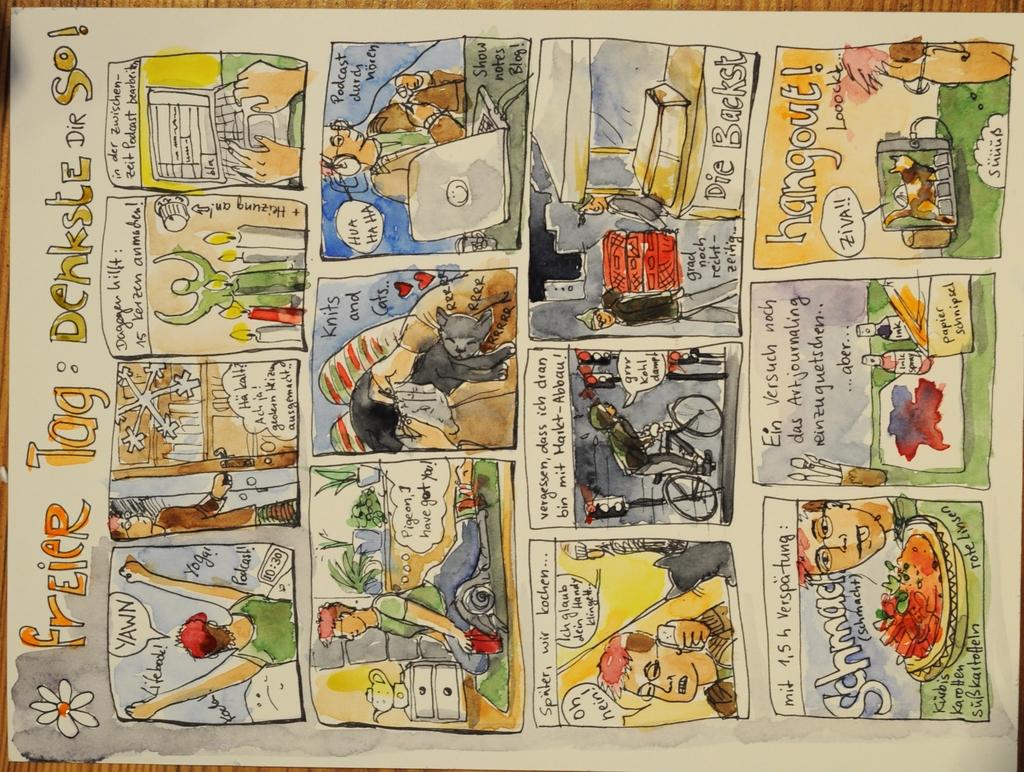What type of tag is in the title of the comic?
Provide a succinct answer. Freier. 